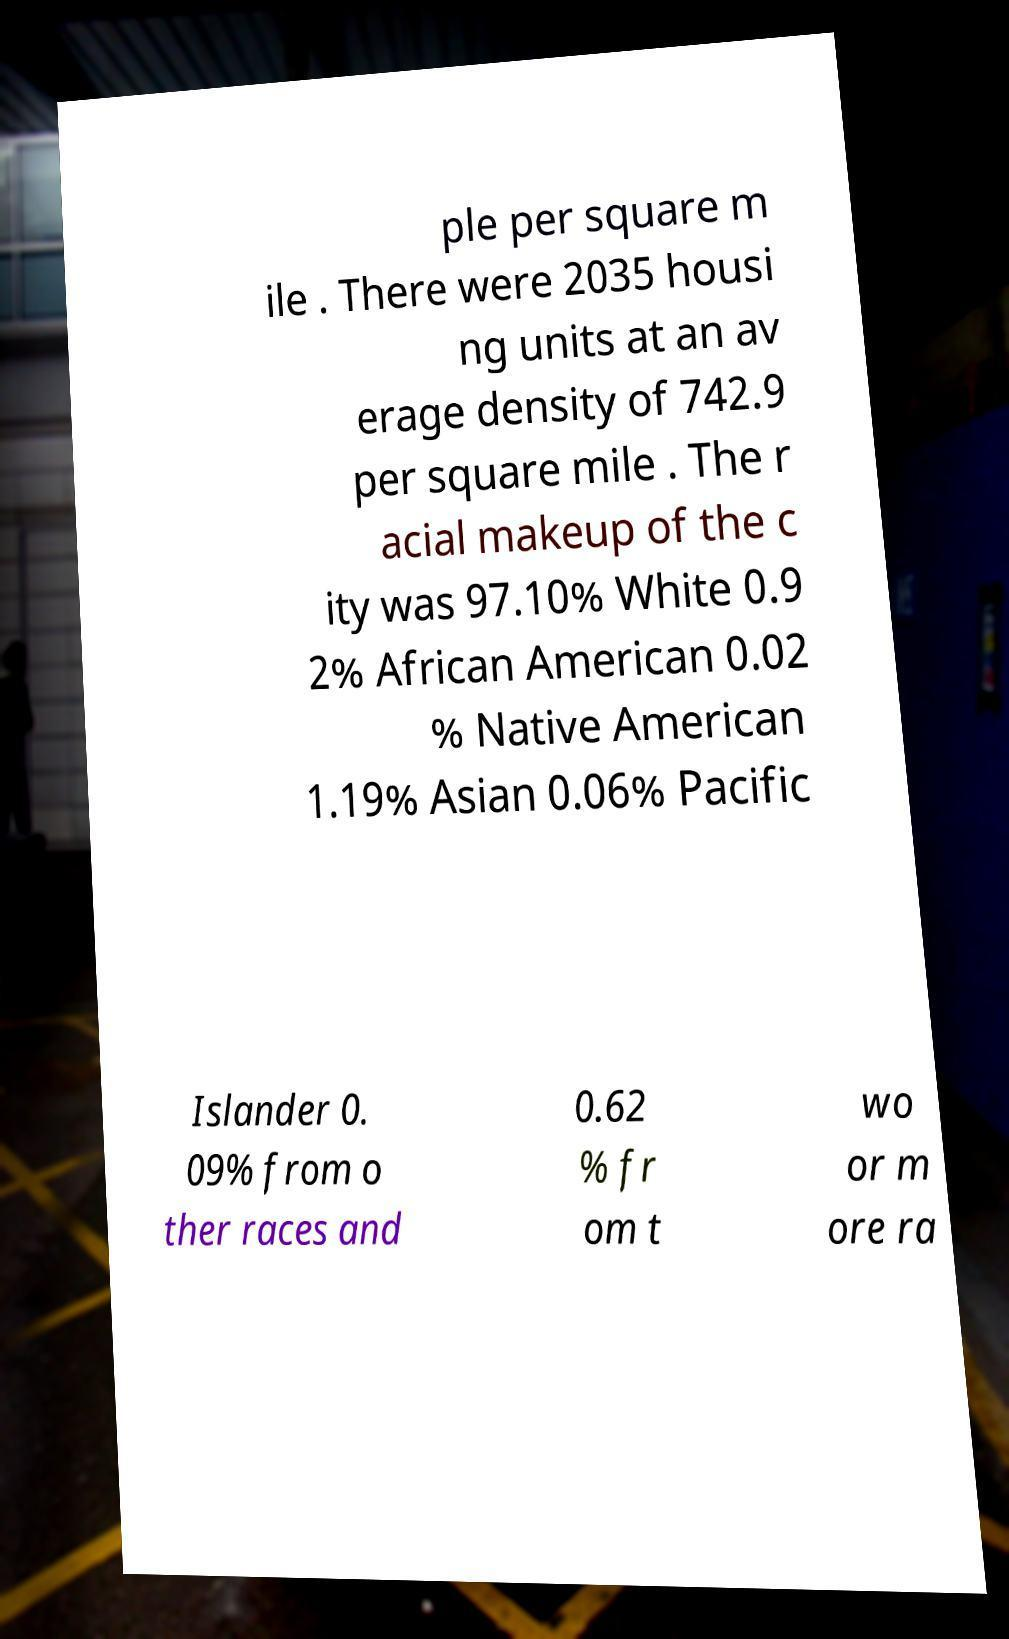I need the written content from this picture converted into text. Can you do that? ple per square m ile . There were 2035 housi ng units at an av erage density of 742.9 per square mile . The r acial makeup of the c ity was 97.10% White 0.9 2% African American 0.02 % Native American 1.19% Asian 0.06% Pacific Islander 0. 09% from o ther races and 0.62 % fr om t wo or m ore ra 